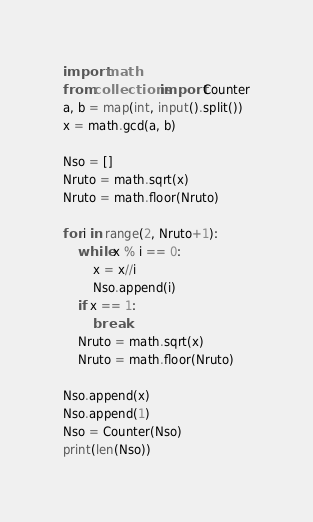<code> <loc_0><loc_0><loc_500><loc_500><_Python_>import math
from collections import Counter
a, b = map(int, input().split())
x = math.gcd(a, b)

Nso = []
Nruto = math.sqrt(x)
Nruto = math.floor(Nruto)

for i in range(2, Nruto+1):
    while x % i == 0:
        x = x//i
        Nso.append(i)
    if x == 1:
        break
    Nruto = math.sqrt(x)
    Nruto = math.floor(Nruto)

Nso.append(x)
Nso.append(1)
Nso = Counter(Nso)
print(len(Nso))
</code> 